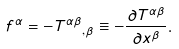Convert formula to latex. <formula><loc_0><loc_0><loc_500><loc_500>f ^ { \alpha } = - { T ^ { \alpha \beta } } _ { , \beta } \equiv - { \frac { \partial T ^ { \alpha \beta } } { \partial x ^ { \beta } } } .</formula> 